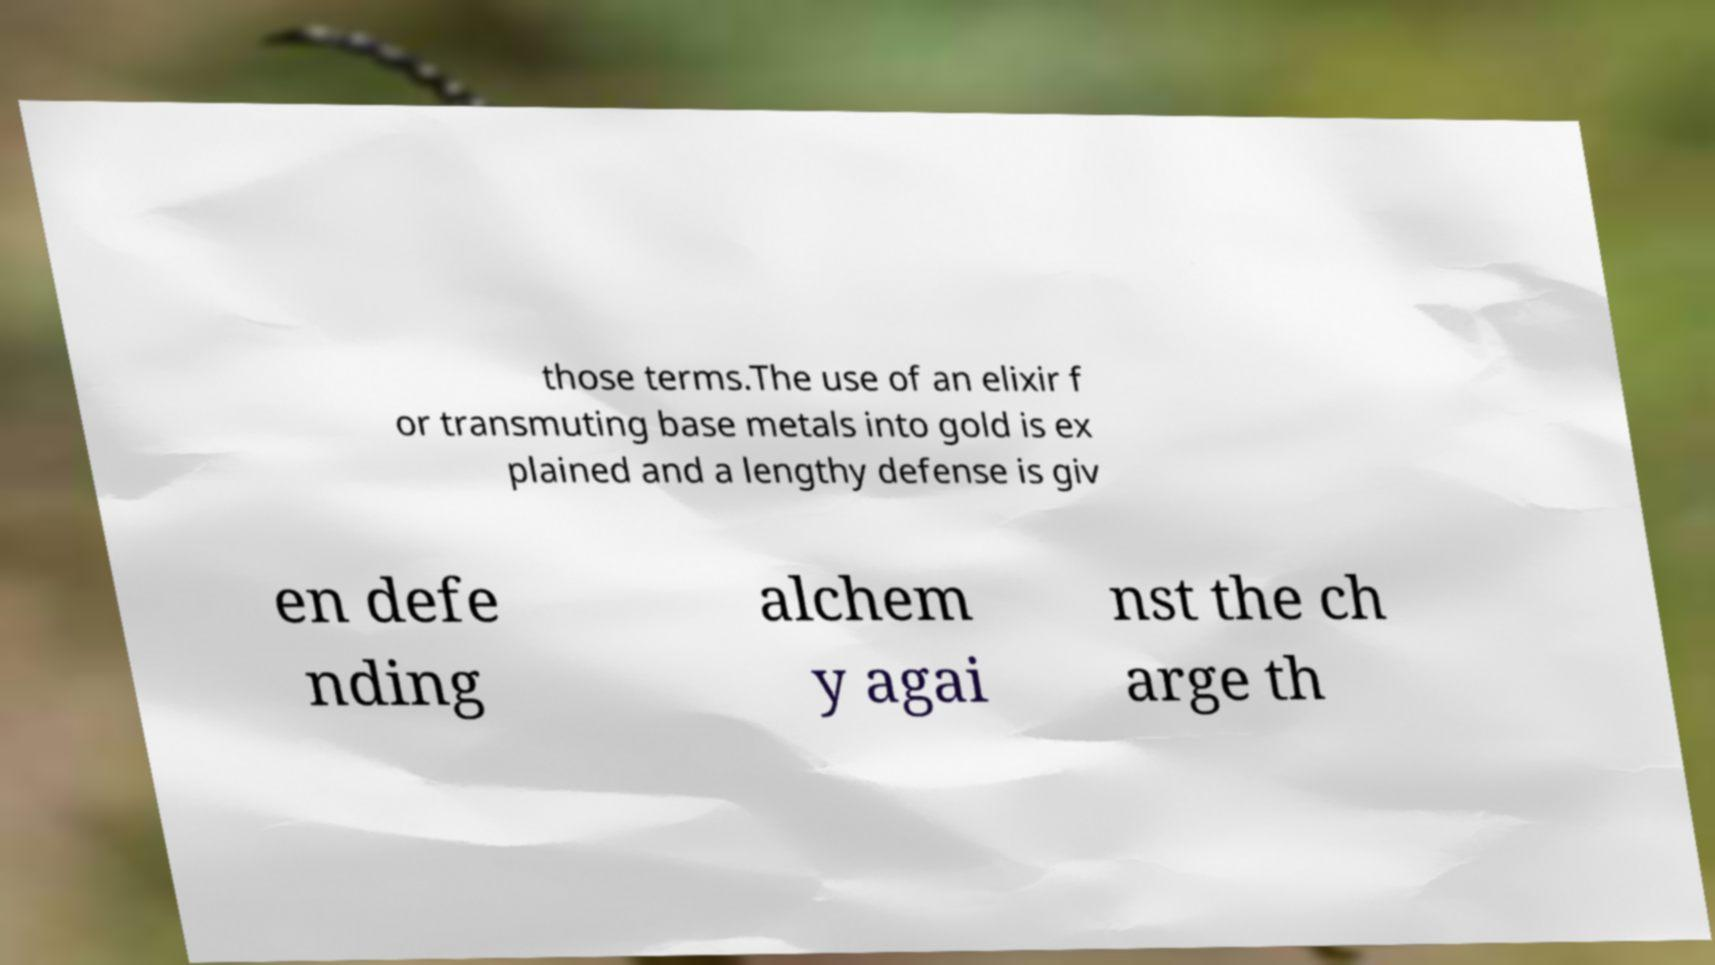Could you assist in decoding the text presented in this image and type it out clearly? those terms.The use of an elixir f or transmuting base metals into gold is ex plained and a lengthy defense is giv en defe nding alchem y agai nst the ch arge th 